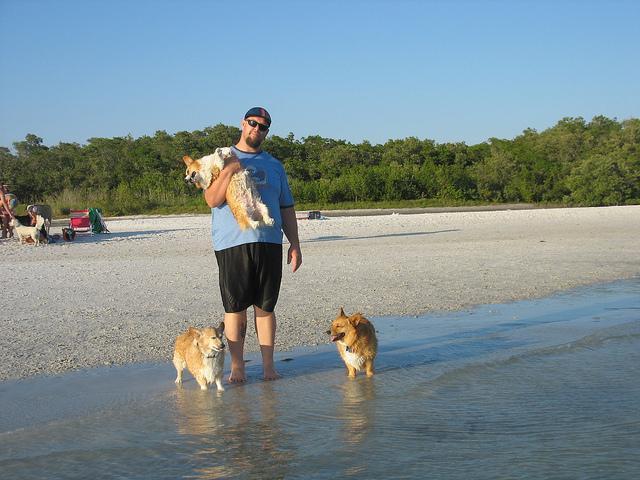How many dogs are there?
Give a very brief answer. 3. How many baby elephants statues on the left of the mother elephants ?
Give a very brief answer. 0. 